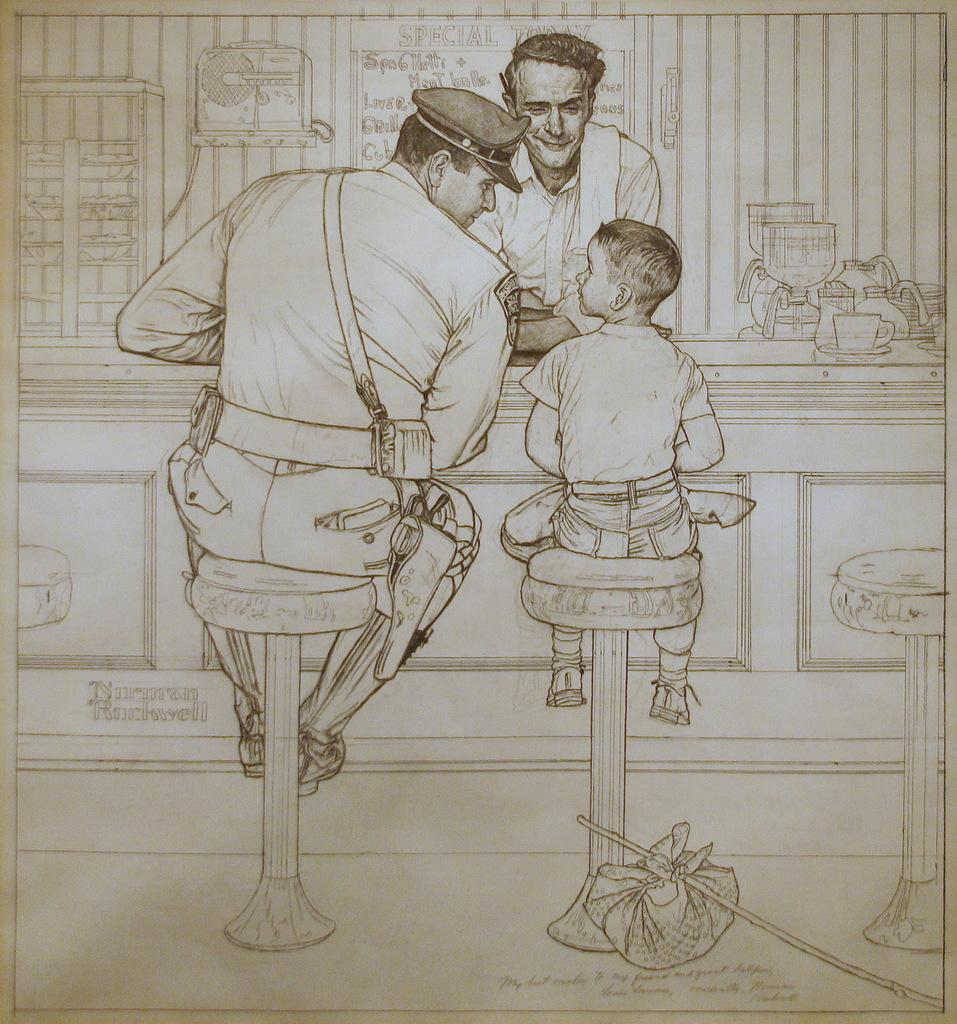What is depicted in the image? There is a drawing in the image. What elements are included in the drawing? The drawing contains people, chairs, text, and objects. What type of notebook is being used in the drawing? There is no notebook present in the image, as it features a drawing with people, chairs, text, and objects. 